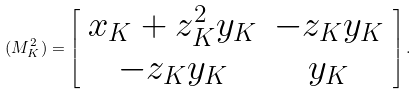Convert formula to latex. <formula><loc_0><loc_0><loc_500><loc_500>( M _ { K } ^ { 2 } ) = \left [ \begin{array} { c c } x _ { K } + z _ { K } ^ { 2 } y _ { K } & - z _ { K } y _ { K } \\ - z _ { K } y _ { K } & y _ { K } \end{array} \right ] .</formula> 